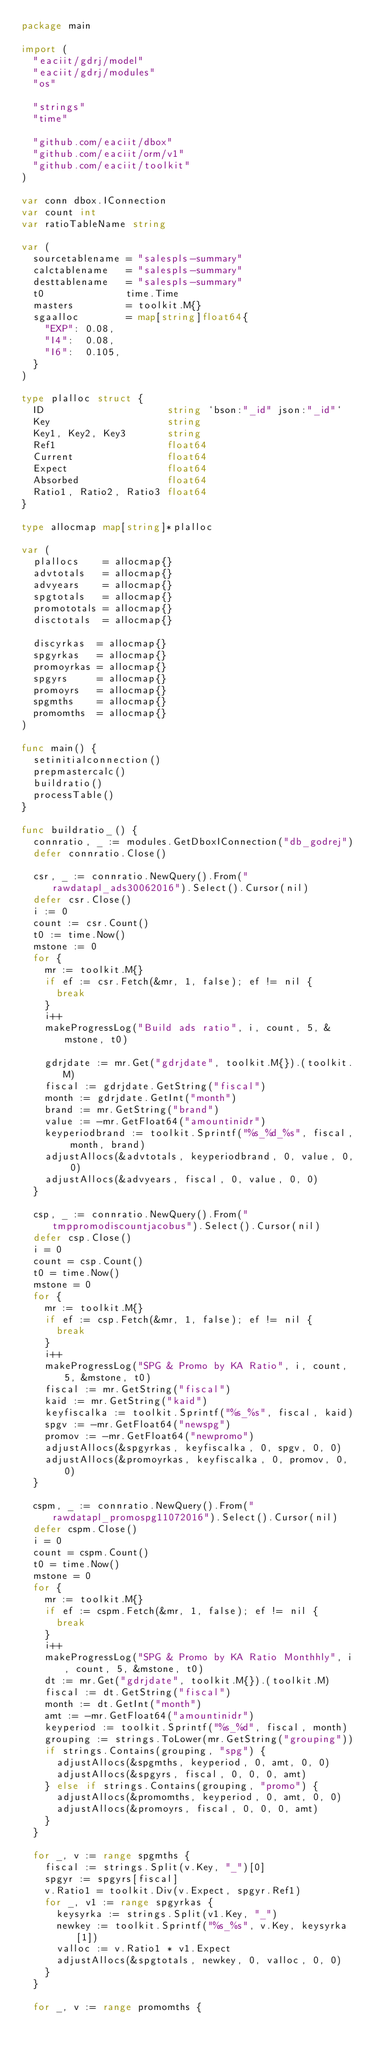<code> <loc_0><loc_0><loc_500><loc_500><_Go_>package main

import (
	"eaciit/gdrj/model"
	"eaciit/gdrj/modules"
	"os"

	"strings"
	"time"

	"github.com/eaciit/dbox"
	"github.com/eaciit/orm/v1"
	"github.com/eaciit/toolkit"
)

var conn dbox.IConnection
var count int
var ratioTableName string

var (
	sourcetablename = "salespls-summary"
	calctablename   = "salespls-summary"
	desttablename   = "salespls-summary"
	t0              time.Time
	masters         = toolkit.M{}
	sgaalloc        = map[string]float64{
		"EXP": 0.08,
		"I4":  0.08,
		"I6":  0.105,
	}
)

type plalloc struct {
	ID                     string `bson:"_id" json:"_id"`
	Key                    string
	Key1, Key2, Key3       string
	Ref1                   float64
	Current                float64
	Expect                 float64
	Absorbed               float64
	Ratio1, Ratio2, Ratio3 float64
}

type allocmap map[string]*plalloc

var (
	plallocs    = allocmap{}
	advtotals   = allocmap{}
	advyears    = allocmap{}
	spgtotals   = allocmap{}
	promototals = allocmap{}
	disctotals  = allocmap{}

	discyrkas  = allocmap{}
	spgyrkas   = allocmap{}
	promoyrkas = allocmap{}
	spgyrs     = allocmap{}
	promoyrs   = allocmap{}
	spgmths    = allocmap{}
	promomths  = allocmap{}
)

func main() {
	setinitialconnection()
	prepmastercalc()
	buildratio()
	processTable()
}

func buildratio_() {
	connratio, _ := modules.GetDboxIConnection("db_godrej")
	defer connratio.Close()

	csr, _ := connratio.NewQuery().From("rawdatapl_ads30062016").Select().Cursor(nil)
	defer csr.Close()
	i := 0
	count := csr.Count()
	t0 := time.Now()
	mstone := 0
	for {
		mr := toolkit.M{}
		if ef := csr.Fetch(&mr, 1, false); ef != nil {
			break
		}
		i++
		makeProgressLog("Build ads ratio", i, count, 5, &mstone, t0)

		gdrjdate := mr.Get("gdrjdate", toolkit.M{}).(toolkit.M)
		fiscal := gdrjdate.GetString("fiscal")
		month := gdrjdate.GetInt("month")
		brand := mr.GetString("brand")
		value := -mr.GetFloat64("amountinidr")
		keyperiodbrand := toolkit.Sprintf("%s_%d_%s", fiscal, month, brand)
		adjustAllocs(&advtotals, keyperiodbrand, 0, value, 0, 0)
		adjustAllocs(&advyears, fiscal, 0, value, 0, 0)
	}

	csp, _ := connratio.NewQuery().From("tmppromodiscountjacobus").Select().Cursor(nil)
	defer csp.Close()
	i = 0
	count = csp.Count()
	t0 = time.Now()
	mstone = 0
	for {
		mr := toolkit.M{}
		if ef := csp.Fetch(&mr, 1, false); ef != nil {
			break
		}
		i++
		makeProgressLog("SPG & Promo by KA Ratio", i, count, 5, &mstone, t0)
		fiscal := mr.GetString("fiscal")
		kaid := mr.GetString("kaid")
		keyfiscalka := toolkit.Sprintf("%s_%s", fiscal, kaid)
		spgv := -mr.GetFloat64("newspg")
		promov := -mr.GetFloat64("newpromo")
		adjustAllocs(&spgyrkas, keyfiscalka, 0, spgv, 0, 0)
		adjustAllocs(&promoyrkas, keyfiscalka, 0, promov, 0, 0)
	}

	cspm, _ := connratio.NewQuery().From("rawdatapl_promospg11072016").Select().Cursor(nil)
	defer cspm.Close()
	i = 0
	count = cspm.Count()
	t0 = time.Now()
	mstone = 0
	for {
		mr := toolkit.M{}
		if ef := cspm.Fetch(&mr, 1, false); ef != nil {
			break
		}
		i++
		makeProgressLog("SPG & Promo by KA Ratio Monthhly", i, count, 5, &mstone, t0)
		dt := mr.Get("gdrjdate", toolkit.M{}).(toolkit.M)
		fiscal := dt.GetString("fiscal")
		month := dt.GetInt("month")
		amt := -mr.GetFloat64("amountinidr")
		keyperiod := toolkit.Sprintf("%s_%d", fiscal, month)
		grouping := strings.ToLower(mr.GetString("grouping"))
		if strings.Contains(grouping, "spg") {
			adjustAllocs(&spgmths, keyperiod, 0, amt, 0, 0)
			adjustAllocs(&spgyrs, fiscal, 0, 0, 0, amt)
		} else if strings.Contains(grouping, "promo") {
			adjustAllocs(&promomths, keyperiod, 0, amt, 0, 0)
			adjustAllocs(&promoyrs, fiscal, 0, 0, 0, amt)
		}
	}

	for _, v := range spgmths {
		fiscal := strings.Split(v.Key, "_")[0]
		spgyr := spgyrs[fiscal]
		v.Ratio1 = toolkit.Div(v.Expect, spgyr.Ref1)
		for _, v1 := range spgyrkas {
			keysyrka := strings.Split(v1.Key, "_")
			newkey := toolkit.Sprintf("%s_%s", v.Key, keysyrka[1])
			valloc := v.Ratio1 * v1.Expect
			adjustAllocs(&spgtotals, newkey, 0, valloc, 0, 0)
		}
	}

	for _, v := range promomths {</code> 